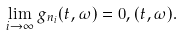Convert formula to latex. <formula><loc_0><loc_0><loc_500><loc_500>\lim _ { i \rightarrow \infty } g _ { n _ { i } } ( t , \omega ) = 0 , ( t , \omega ) .</formula> 